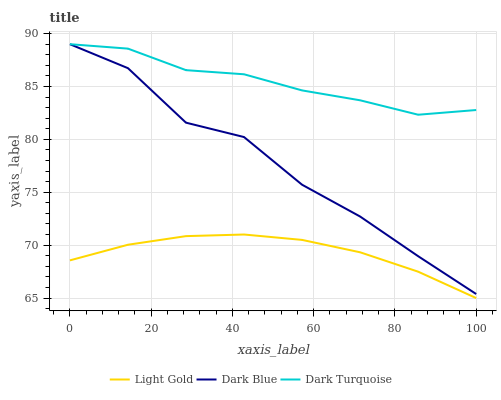Does Light Gold have the minimum area under the curve?
Answer yes or no. Yes. Does Dark Turquoise have the maximum area under the curve?
Answer yes or no. Yes. Does Dark Turquoise have the minimum area under the curve?
Answer yes or no. No. Does Light Gold have the maximum area under the curve?
Answer yes or no. No. Is Light Gold the smoothest?
Answer yes or no. Yes. Is Dark Blue the roughest?
Answer yes or no. Yes. Is Dark Turquoise the smoothest?
Answer yes or no. No. Is Dark Turquoise the roughest?
Answer yes or no. No. Does Light Gold have the lowest value?
Answer yes or no. Yes. Does Dark Turquoise have the lowest value?
Answer yes or no. No. Does Dark Turquoise have the highest value?
Answer yes or no. Yes. Does Light Gold have the highest value?
Answer yes or no. No. Is Light Gold less than Dark Blue?
Answer yes or no. Yes. Is Dark Turquoise greater than Light Gold?
Answer yes or no. Yes. Does Dark Turquoise intersect Dark Blue?
Answer yes or no. Yes. Is Dark Turquoise less than Dark Blue?
Answer yes or no. No. Is Dark Turquoise greater than Dark Blue?
Answer yes or no. No. Does Light Gold intersect Dark Blue?
Answer yes or no. No. 